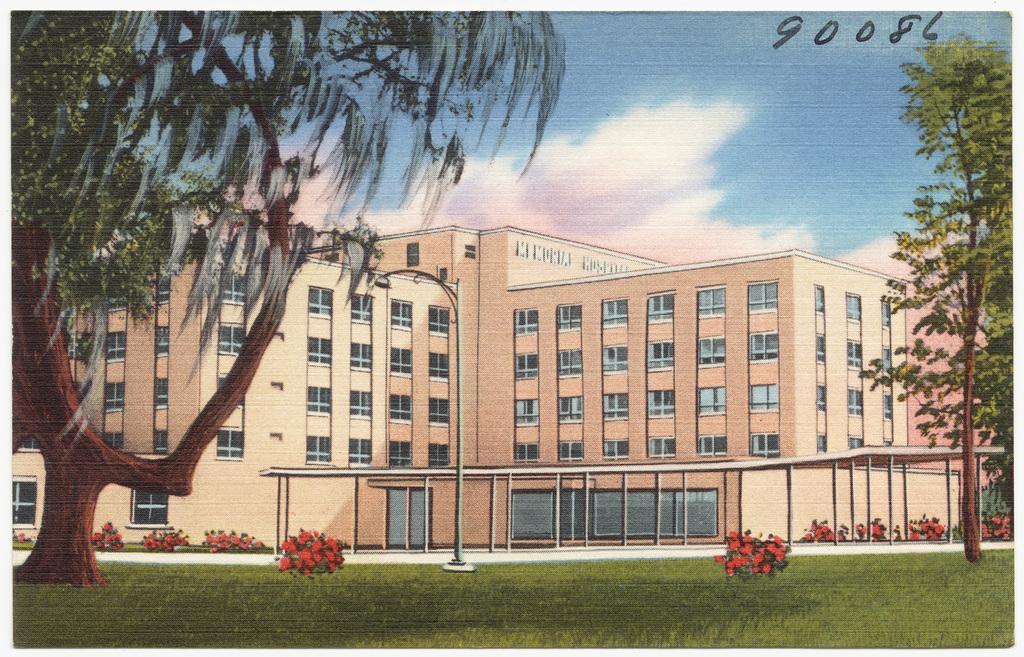How would you summarize this image in a sentence or two? It seems to be the image is outside of the building. In the image on right side we can see some trees and plants with flowers, on left side we can also see some trees in middle there is a street light,building,windows at bottom there is a grass and sky is on top. 